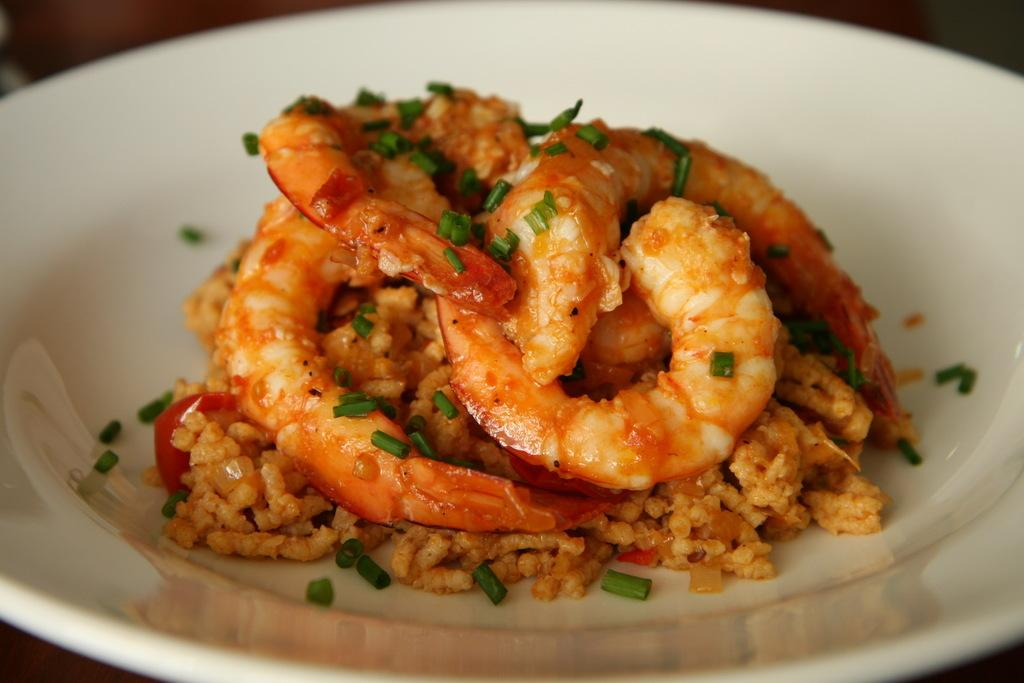What is present on the plate in the image? The plate contains food items. Can you describe the setting in which the plate is located? The image was likely taken in a room. What historical event is depicted on the flag in the image? There is no flag present in the image, so it is not possible to answer that question. 